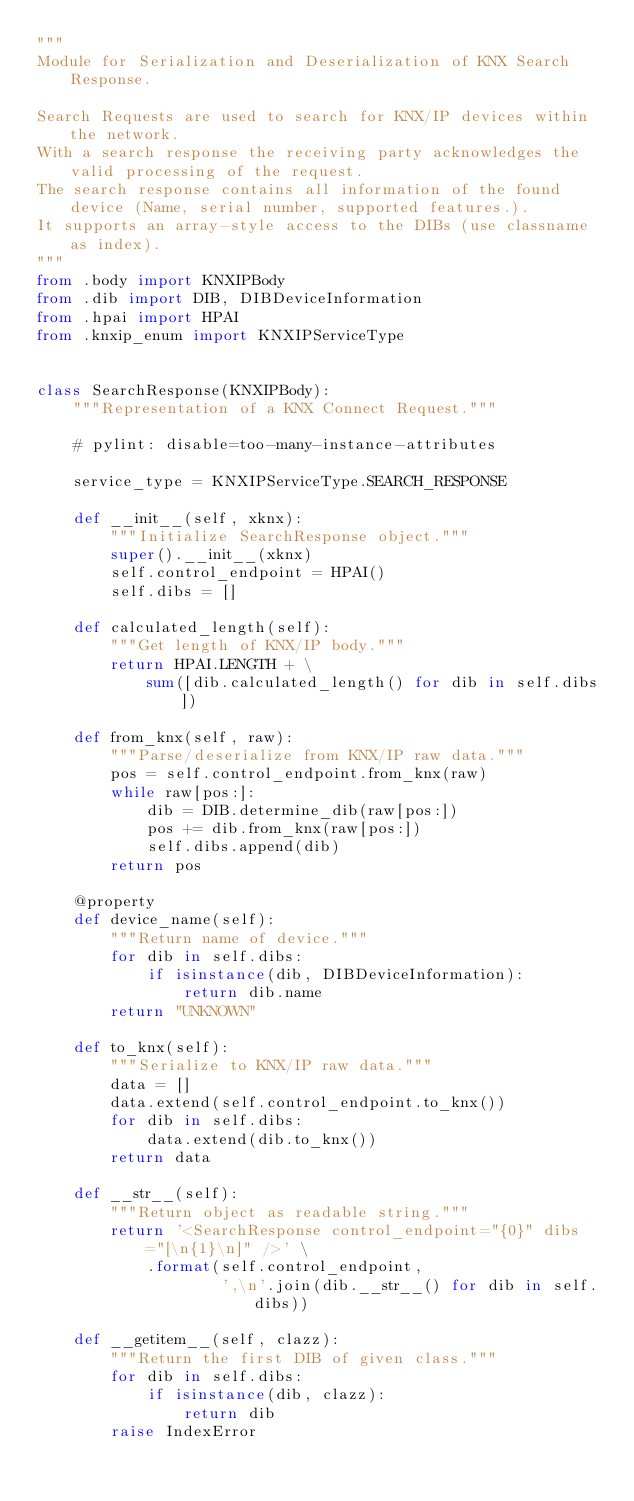<code> <loc_0><loc_0><loc_500><loc_500><_Python_>"""
Module for Serialization and Deserialization of KNX Search Response.

Search Requests are used to search for KNX/IP devices within the network.
With a search response the receiving party acknowledges the valid processing of the request.
The search response contains all information of the found device (Name, serial number, supported features.).
It supports an array-style access to the DIBs (use classname as index).
"""
from .body import KNXIPBody
from .dib import DIB, DIBDeviceInformation
from .hpai import HPAI
from .knxip_enum import KNXIPServiceType


class SearchResponse(KNXIPBody):
    """Representation of a KNX Connect Request."""

    # pylint: disable=too-many-instance-attributes

    service_type = KNXIPServiceType.SEARCH_RESPONSE

    def __init__(self, xknx):
        """Initialize SearchResponse object."""
        super().__init__(xknx)
        self.control_endpoint = HPAI()
        self.dibs = []

    def calculated_length(self):
        """Get length of KNX/IP body."""
        return HPAI.LENGTH + \
            sum([dib.calculated_length() for dib in self.dibs])

    def from_knx(self, raw):
        """Parse/deserialize from KNX/IP raw data."""
        pos = self.control_endpoint.from_knx(raw)
        while raw[pos:]:
            dib = DIB.determine_dib(raw[pos:])
            pos += dib.from_knx(raw[pos:])
            self.dibs.append(dib)
        return pos

    @property
    def device_name(self):
        """Return name of device."""
        for dib in self.dibs:
            if isinstance(dib, DIBDeviceInformation):
                return dib.name
        return "UNKNOWN"

    def to_knx(self):
        """Serialize to KNX/IP raw data."""
        data = []
        data.extend(self.control_endpoint.to_knx())
        for dib in self.dibs:
            data.extend(dib.to_knx())
        return data

    def __str__(self):
        """Return object as readable string."""
        return '<SearchResponse control_endpoint="{0}" dibs="[\n{1}\n]" />' \
            .format(self.control_endpoint,
                    ',\n'.join(dib.__str__() for dib in self.dibs))

    def __getitem__(self, clazz):
        """Return the first DIB of given class."""
        for dib in self.dibs:
            if isinstance(dib, clazz):
                return dib
        raise IndexError
</code> 